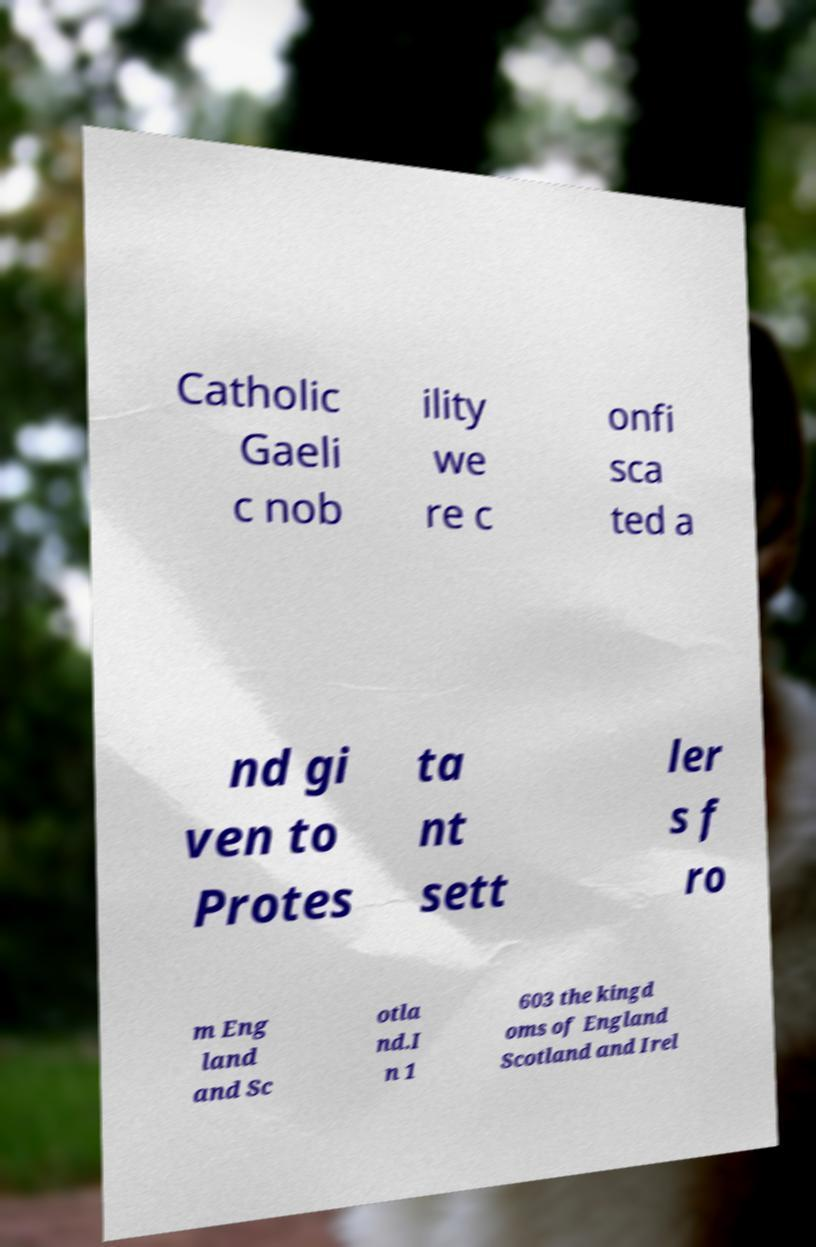I need the written content from this picture converted into text. Can you do that? Catholic Gaeli c nob ility we re c onfi sca ted a nd gi ven to Protes ta nt sett ler s f ro m Eng land and Sc otla nd.I n 1 603 the kingd oms of England Scotland and Irel 